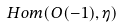Convert formula to latex. <formula><loc_0><loc_0><loc_500><loc_500>H o m ( O ( - 1 ) , \eta )</formula> 